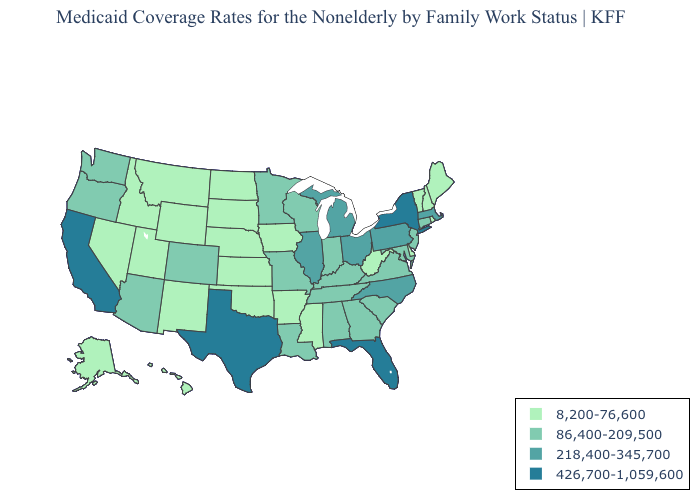Does the map have missing data?
Keep it brief. No. Which states have the lowest value in the West?
Be succinct. Alaska, Hawaii, Idaho, Montana, Nevada, New Mexico, Utah, Wyoming. Does Kansas have the same value as Nebraska?
Answer briefly. Yes. Does Ohio have the highest value in the MidWest?
Answer briefly. Yes. Among the states that border South Carolina , which have the lowest value?
Answer briefly. Georgia. Among the states that border Pennsylvania , which have the highest value?
Quick response, please. New York. Name the states that have a value in the range 86,400-209,500?
Keep it brief. Alabama, Arizona, Colorado, Connecticut, Georgia, Indiana, Kentucky, Louisiana, Maryland, Minnesota, Missouri, New Jersey, Oregon, South Carolina, Tennessee, Virginia, Washington, Wisconsin. Does Florida have the highest value in the USA?
Give a very brief answer. Yes. Does Texas have a lower value than Arizona?
Short answer required. No. What is the value of Texas?
Concise answer only. 426,700-1,059,600. Does the map have missing data?
Quick response, please. No. Which states have the highest value in the USA?
Give a very brief answer. California, Florida, New York, Texas. Among the states that border Mississippi , does Arkansas have the highest value?
Be succinct. No. Name the states that have a value in the range 86,400-209,500?
Write a very short answer. Alabama, Arizona, Colorado, Connecticut, Georgia, Indiana, Kentucky, Louisiana, Maryland, Minnesota, Missouri, New Jersey, Oregon, South Carolina, Tennessee, Virginia, Washington, Wisconsin. What is the value of Minnesota?
Quick response, please. 86,400-209,500. 